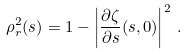<formula> <loc_0><loc_0><loc_500><loc_500>\rho _ { r } ^ { 2 } ( s ) = 1 - \left | \frac { \partial \zeta } { \partial s } ( s , 0 ) \right | ^ { 2 } \, .</formula> 